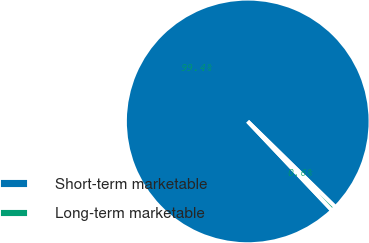Convert chart to OTSL. <chart><loc_0><loc_0><loc_500><loc_500><pie_chart><fcel>Short-term marketable<fcel>Long-term marketable<nl><fcel>99.39%<fcel>0.61%<nl></chart> 